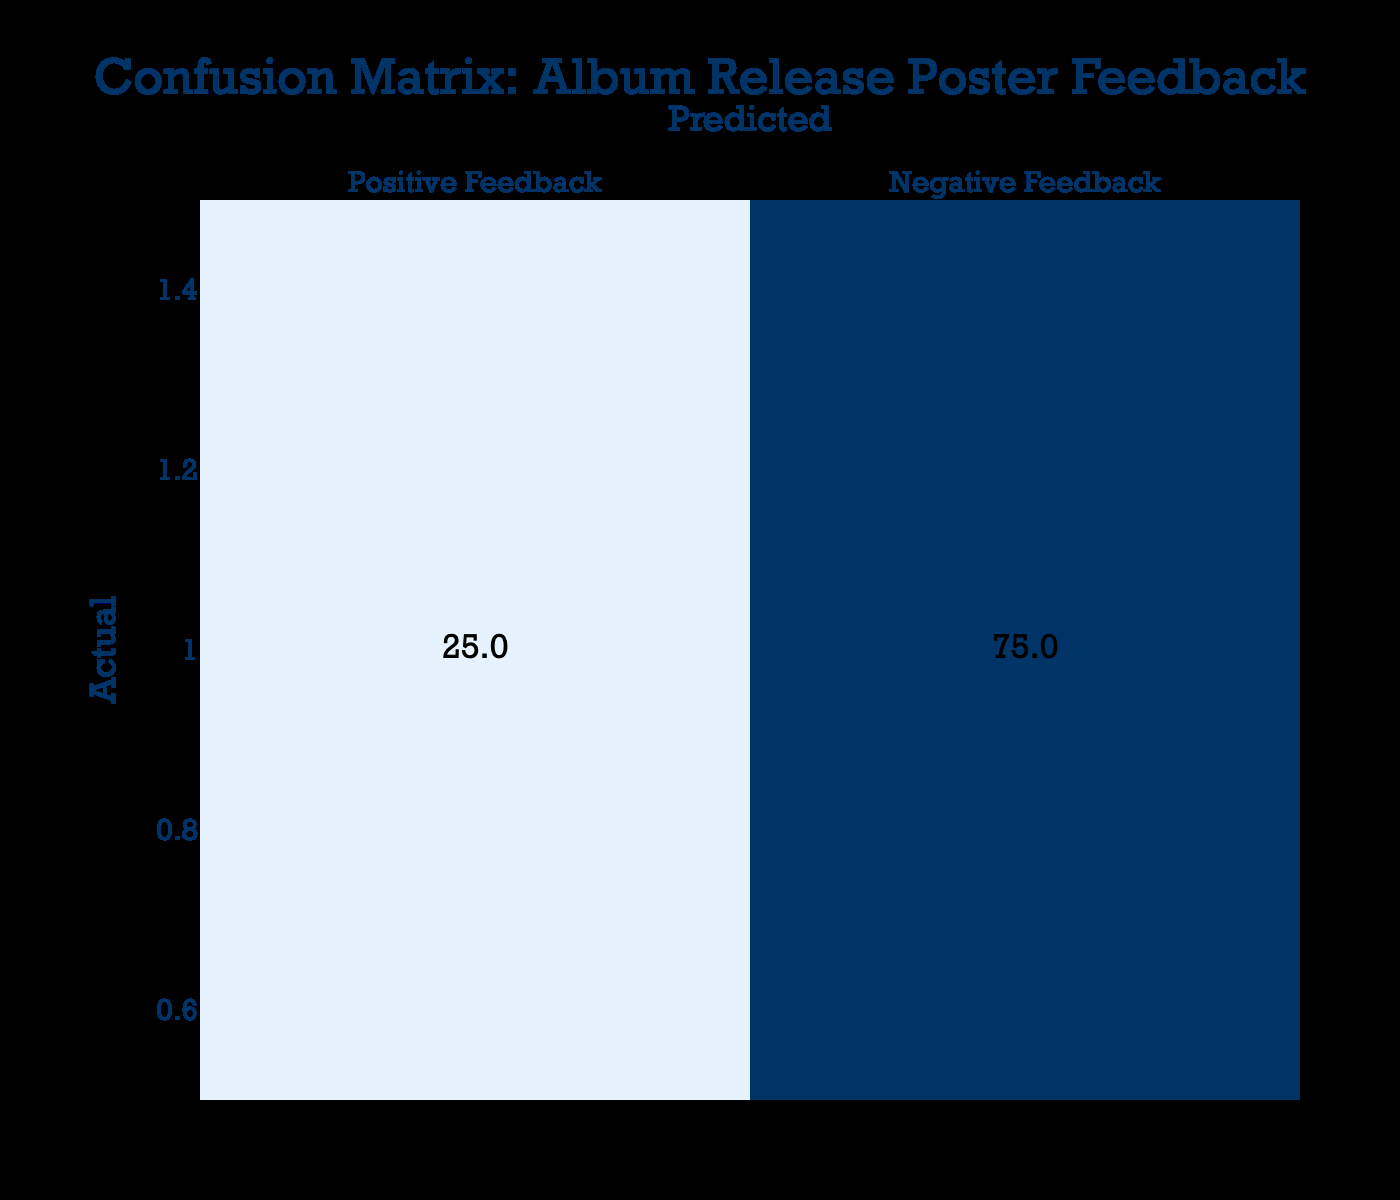What is the total number of respondents who provided positive feedback? To find the total number of respondents who provided positive feedback, I need to add the values in the "Positive Feedback" column. From the table, this is 220 (true positives) + 25 (false negatives) = 245.
Answer: 245 What is the total number of respondents who provided negative feedback? To find the total number of respondents who provided negative feedback, I need to add the values in the "Negative Feedback" column. From the table, this is 30 (false positives) + 75 (true negatives) = 105.
Answer: 105 What percentage of actual positive feedback was predicted correctly? To find the percentage of actual positive feedback predicted correctly, I take the number of true positives (220) and divide it by the total number of actual positive feedback (220 + 30). This gives me 220 / 250 = 0.88. To express this as a percentage, I multiply by 100, resulting in 88%.
Answer: 88% Is the number of true positives greater than the number of true negatives? Comparing the values, the number of true positives is 220 while the number of true negatives is 75. Since 220 is indeed greater than 75, the answer is yes.
Answer: Yes What is the difference between false positives and false negatives? To find the difference, I subtract the number of false negatives (30) from the number of false positives (25). So, the calculation is 25 - 30 = -5, indicating that there are more false negatives than false positives.
Answer: -5 What is the total number of predictions made? The total number of predictions made is the sum of all values in the matrix. Adding them together gives me 220 + 30 + 25 + 75 = 350.
Answer: 350 What proportion of the total respondents had negative feedback predicted incorrectly? To find the proportion of negative feedback predicted incorrectly, I first determine the number of false positives (30) and the total number of respondents (350). The proportion is calculated as 30 / 350, which simplifies to approximately 0.086 or 8.6%.
Answer: 8.6% How many respondents provided feedback where the prediction was correct? To find the number of respondents who had their feedback predicted correctly, I add the true positives (220) and true negatives (75), yielding a total of 295 respondents whose feedback was accurately predicted.
Answer: 295 